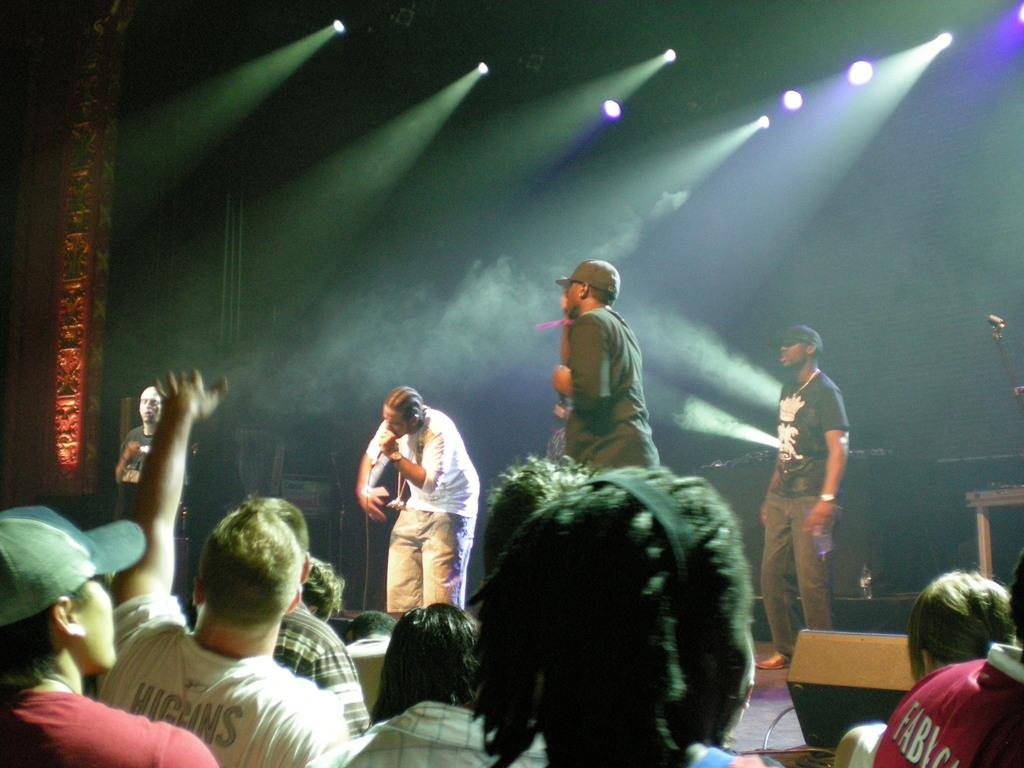What type of event is taking place in the image? The image depicts a musical concert. Who is on the stage during the concert? There are persons on the stage. What is one person on the stage using? One person is holding a microphone. What can be seen at the top of the image? There are lights at the top of the image. Where are the other persons located in the image? There are persons at the bottom of the image. What type of footwear is the person wearing on stage? The image does not provide information about the footwear of the person on stage. What type of apparel is the person wearing on stage? The image does not provide information about the apparel of the person on stage. 